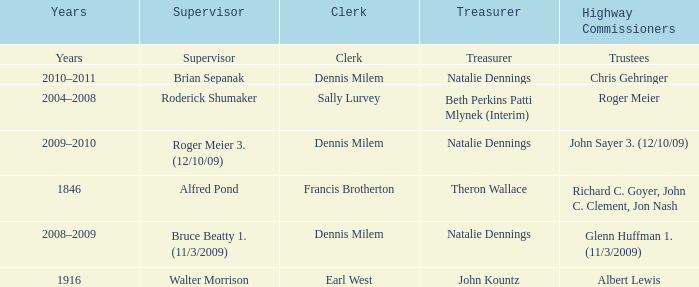Who was the supervisor in the year 1846? Alfred Pond. 